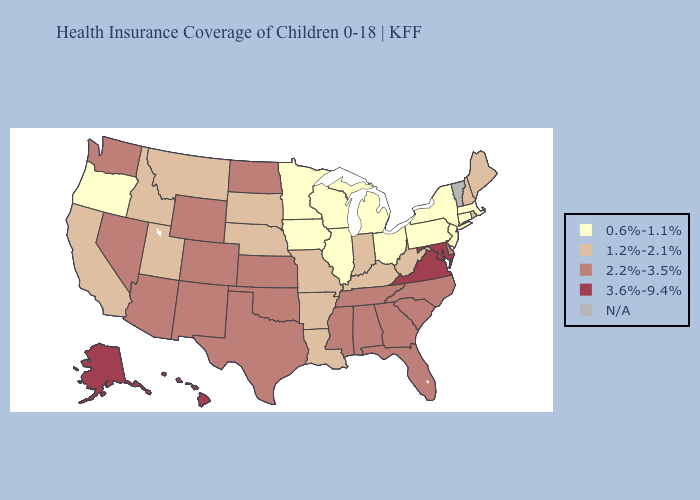Among the states that border Virginia , does Tennessee have the lowest value?
Give a very brief answer. No. Name the states that have a value in the range 2.2%-3.5%?
Answer briefly. Alabama, Arizona, Colorado, Delaware, Florida, Georgia, Kansas, Mississippi, Nevada, New Mexico, North Carolina, North Dakota, Oklahoma, South Carolina, Tennessee, Texas, Washington, Wyoming. What is the highest value in states that border Louisiana?
Give a very brief answer. 2.2%-3.5%. What is the value of New Hampshire?
Answer briefly. 1.2%-2.1%. Is the legend a continuous bar?
Give a very brief answer. No. Name the states that have a value in the range 0.6%-1.1%?
Answer briefly. Connecticut, Illinois, Iowa, Massachusetts, Michigan, Minnesota, New Jersey, New York, Ohio, Oregon, Pennsylvania, Wisconsin. Which states have the lowest value in the USA?
Short answer required. Connecticut, Illinois, Iowa, Massachusetts, Michigan, Minnesota, New Jersey, New York, Ohio, Oregon, Pennsylvania, Wisconsin. Which states have the highest value in the USA?
Be succinct. Alaska, Hawaii, Maryland, Virginia. What is the highest value in states that border Connecticut?
Quick response, please. 1.2%-2.1%. Among the states that border Wisconsin , which have the lowest value?
Answer briefly. Illinois, Iowa, Michigan, Minnesota. What is the value of North Dakota?
Keep it brief. 2.2%-3.5%. What is the value of Kansas?
Give a very brief answer. 2.2%-3.5%. What is the value of Mississippi?
Answer briefly. 2.2%-3.5%. Does Maine have the lowest value in the USA?
Answer briefly. No. 